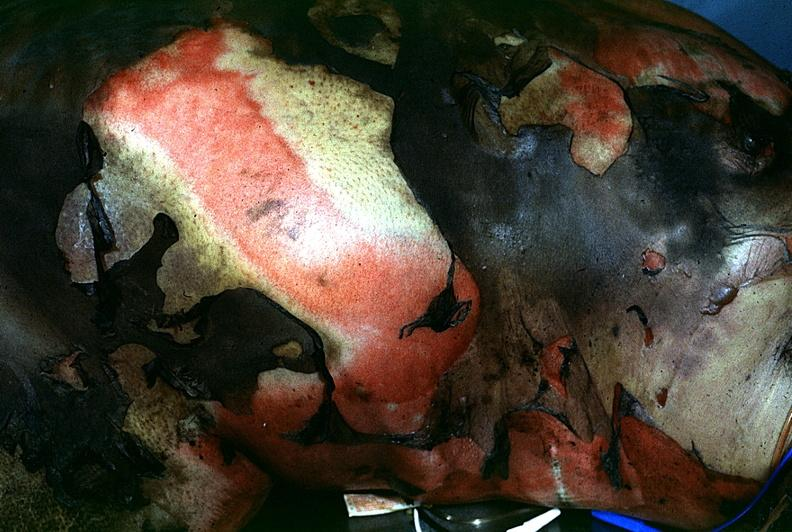does hypersegmented neutrophil show thermal burn?
Answer the question using a single word or phrase. No 